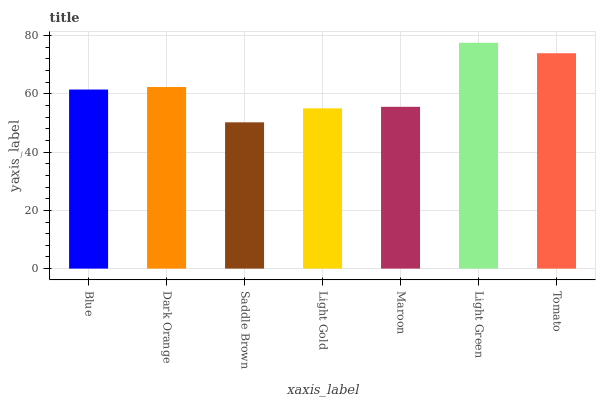Is Saddle Brown the minimum?
Answer yes or no. Yes. Is Light Green the maximum?
Answer yes or no. Yes. Is Dark Orange the minimum?
Answer yes or no. No. Is Dark Orange the maximum?
Answer yes or no. No. Is Dark Orange greater than Blue?
Answer yes or no. Yes. Is Blue less than Dark Orange?
Answer yes or no. Yes. Is Blue greater than Dark Orange?
Answer yes or no. No. Is Dark Orange less than Blue?
Answer yes or no. No. Is Blue the high median?
Answer yes or no. Yes. Is Blue the low median?
Answer yes or no. Yes. Is Tomato the high median?
Answer yes or no. No. Is Tomato the low median?
Answer yes or no. No. 